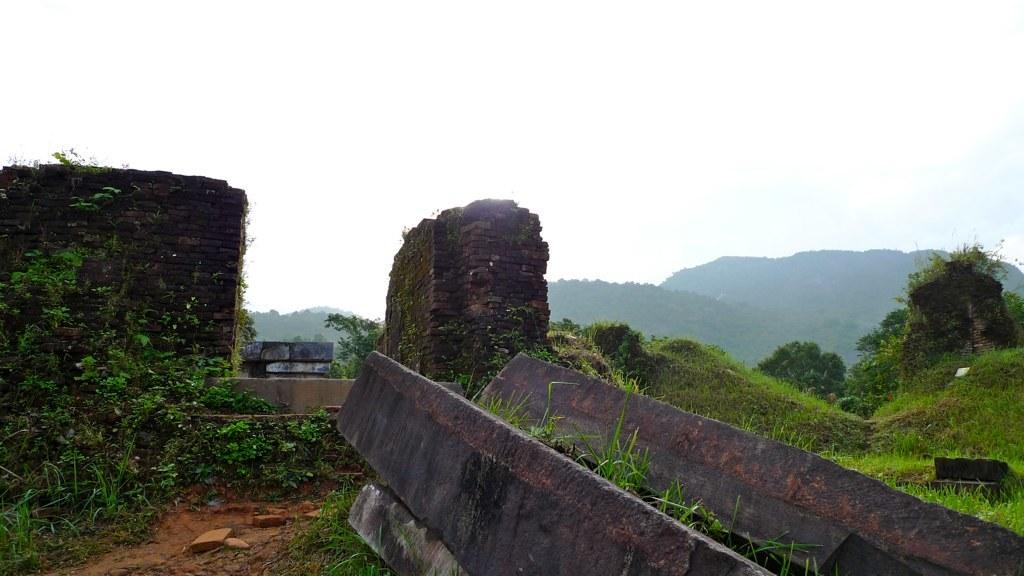What type of terrain is visible on the surface in the image? There are rocks and grass on the surface in the image. What geographical features can be seen in the background of the image? There are mountains visible in the background of the image. What grade of wood is used to construct the crate in the image? There is no crate present in the image, so it is not possible to determine the grade of wood used. 